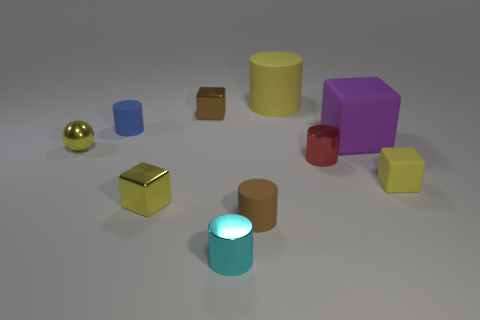Subtract 1 cylinders. How many cylinders are left? 4 Subtract all green cylinders. Subtract all purple blocks. How many cylinders are left? 5 Subtract all cubes. How many objects are left? 6 Subtract all tiny yellow spheres. Subtract all small yellow spheres. How many objects are left? 8 Add 6 small brown matte objects. How many small brown matte objects are left? 7 Add 3 cyan things. How many cyan things exist? 4 Subtract 0 purple cylinders. How many objects are left? 10 